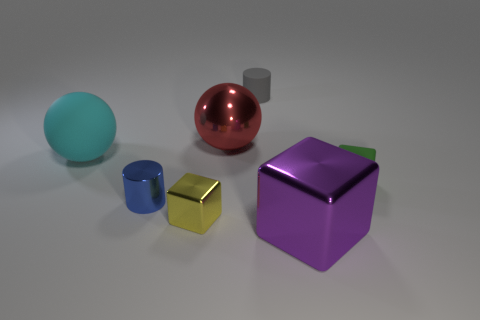There is a shiny thing on the left side of the metal cube that is to the left of the large purple block in front of the tiny yellow cube; how big is it?
Offer a terse response. Small. Are there the same number of large metal objects that are on the right side of the red sphere and small matte cubes that are behind the big purple cube?
Your response must be concise. Yes. What size is the cylinder that is the same material as the tiny green cube?
Your answer should be compact. Small. The big rubber ball is what color?
Provide a short and direct response. Cyan. How many large rubber objects are the same color as the large block?
Keep it short and to the point. 0. There is a green object that is the same size as the yellow metal cube; what is it made of?
Make the answer very short. Rubber. There is a big purple thing that is in front of the matte sphere; are there any large rubber balls that are on the right side of it?
Offer a terse response. No. What number of other things are the same color as the tiny matte block?
Make the answer very short. 0. The gray matte cylinder has what size?
Make the answer very short. Small. Are any small red rubber cubes visible?
Give a very brief answer. No. 